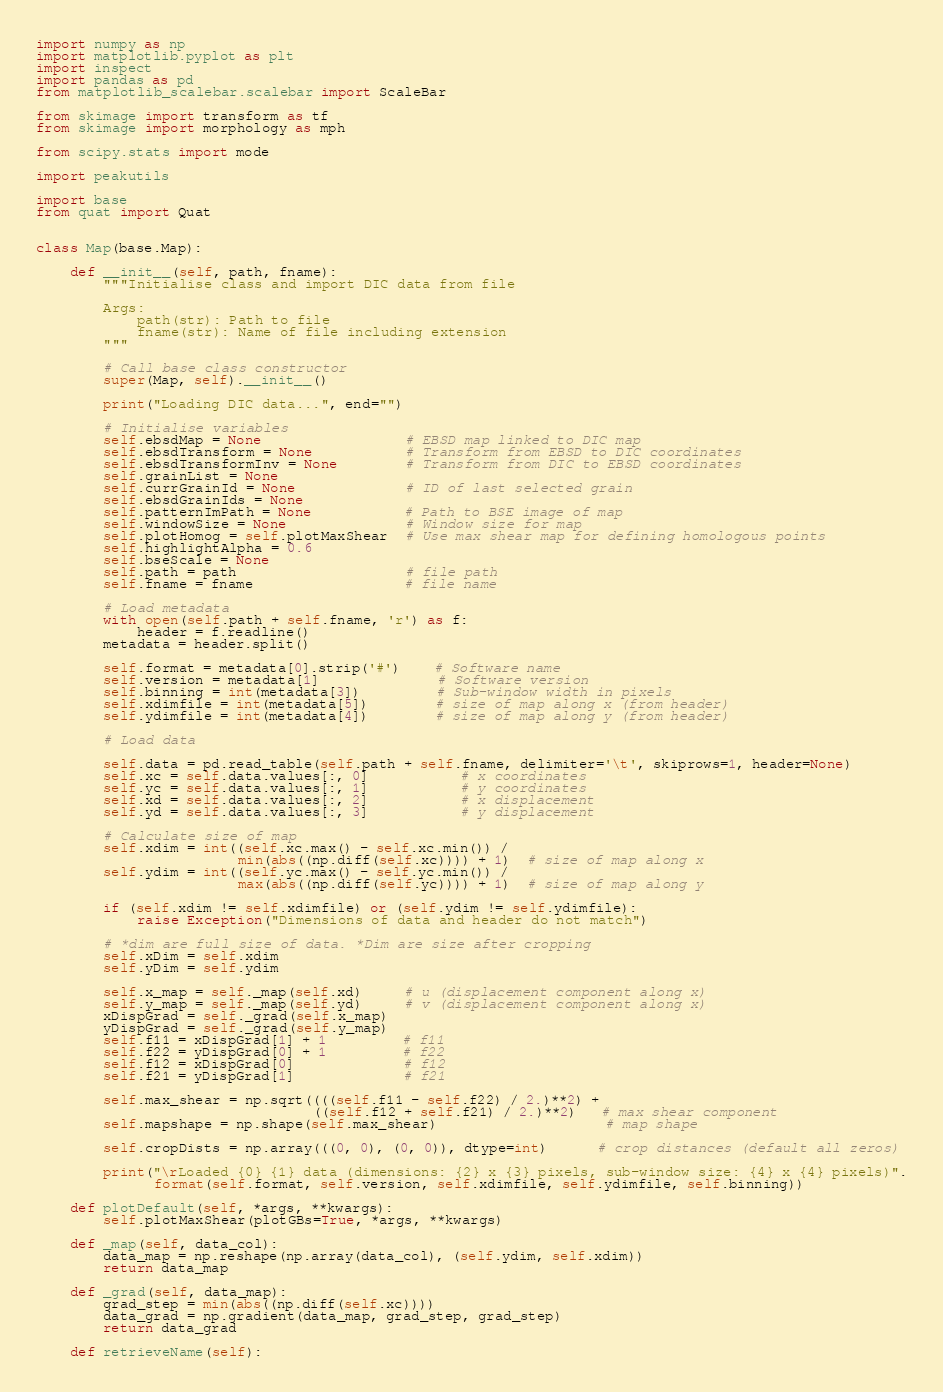<code> <loc_0><loc_0><loc_500><loc_500><_Python_>import numpy as np
import matplotlib.pyplot as plt
import inspect
import pandas as pd
from matplotlib_scalebar.scalebar import ScaleBar

from skimage import transform as tf
from skimage import morphology as mph

from scipy.stats import mode

import peakutils

import base
from quat import Quat


class Map(base.Map):

    def __init__(self, path, fname):
        """Initialise class and import DIC data from file

        Args:
            path(str): Path to file
            fname(str): Name of file including extension
        """

        # Call base class constructor
        super(Map, self).__init__()

        print("Loading DIC data...", end="")

        # Initialise variables
        self.ebsdMap = None                 # EBSD map linked to DIC map
        self.ebsdTransform = None           # Transform from EBSD to DIC coordinates
        self.ebsdTransformInv = None        # Transform from DIC to EBSD coordinates
        self.grainList = None
        self.currGrainId = None             # ID of last selected grain
        self.ebsdGrainIds = None
        self.patternImPath = None           # Path to BSE image of map
        self.windowSize = None              # Window size for map
        self.plotHomog = self.plotMaxShear  # Use max shear map for defining homologous points
        self.highlightAlpha = 0.6
        self.bseScale = None
        self.path = path                    # file path
        self.fname = fname                  # file name

        # Load metadata
        with open(self.path + self.fname, 'r') as f:
            header = f.readline()
        metadata = header.split()

        self.format = metadata[0].strip('#')    # Software name
        self.version = metadata[1]              # Software version
        self.binning = int(metadata[3])         # Sub-window width in pixels
        self.xdimfile = int(metadata[5])        # size of map along x (from header)
        self.ydimfile = int(metadata[4])        # size of map along y (from header)

        # Load data

        self.data = pd.read_table(self.path + self.fname, delimiter='\t', skiprows=1, header=None)
        self.xc = self.data.values[:, 0]           # x coordinates
        self.yc = self.data.values[:, 1]           # y coordinates
        self.xd = self.data.values[:, 2]           # x displacement
        self.yd = self.data.values[:, 3]           # y displacement

        # Calculate size of map
        self.xdim = int((self.xc.max() - self.xc.min()) /
                        min(abs((np.diff(self.xc)))) + 1)  # size of map along x
        self.ydim = int((self.yc.max() - self.yc.min()) /
                        max(abs((np.diff(self.yc)))) + 1)  # size of map along y

        if (self.xdim != self.xdimfile) or (self.ydim != self.ydimfile):
            raise Exception("Dimensions of data and header do not match")

        # *dim are full size of data. *Dim are size after cropping
        self.xDim = self.xdim
        self.yDim = self.ydim

        self.x_map = self._map(self.xd)     # u (displacement component along x)
        self.y_map = self._map(self.yd)     # v (displacement component along x)
        xDispGrad = self._grad(self.x_map)
        yDispGrad = self._grad(self.y_map)
        self.f11 = xDispGrad[1] + 1         # f11
        self.f22 = yDispGrad[0] + 1         # f22
        self.f12 = xDispGrad[0]             # f12
        self.f21 = yDispGrad[1]             # f21

        self.max_shear = np.sqrt((((self.f11 - self.f22) / 2.)**2) +
                                 ((self.f12 + self.f21) / 2.)**2)   # max shear component
        self.mapshape = np.shape(self.max_shear)                    # map shape

        self.cropDists = np.array(((0, 0), (0, 0)), dtype=int)      # crop distances (default all zeros)

        print("\rLoaded {0} {1} data (dimensions: {2} x {3} pixels, sub-window size: {4} x {4} pixels)".
              format(self.format, self.version, self.xdimfile, self.ydimfile, self.binning))

    def plotDefault(self, *args, **kwargs):
        self.plotMaxShear(plotGBs=True, *args, **kwargs)

    def _map(self, data_col):
        data_map = np.reshape(np.array(data_col), (self.ydim, self.xdim))
        return data_map

    def _grad(self, data_map):
        grad_step = min(abs((np.diff(self.xc))))
        data_grad = np.gradient(data_map, grad_step, grad_step)
        return data_grad

    def retrieveName(self):</code> 